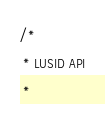<code> <loc_0><loc_0><loc_500><loc_500><_C#_>/* 
 * LUSID API
 *</code> 